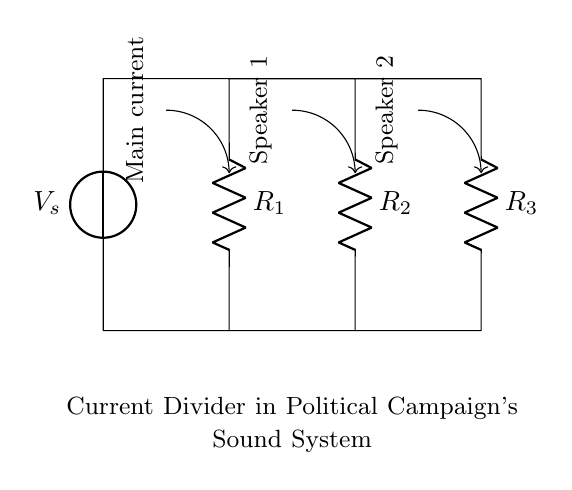What is the source voltage in the circuit? The source voltage is represented as V_s in the diagram, indicating the potential difference provided for the circuit operation.
Answer: V_s How many resistors are present in the circuit? The diagram shows three resistors labeled R_1, R_2, and R_3, indicating that there are three resistors in total.
Answer: 3 Which resistor connects to Speaker 1? Speaker 1 is connected to the output of resistor R_2, as indicated by the arrow leading to it from the current flowing through R_2.
Answer: R_2 What is the function of the current divider in this circuit? The current divider is designed to split the main current into two branches leading to the speakers, allowing for sound distribution among multiple outputs.
Answer: To split current Which component primarily directs the current toward both speakers? The main current flows from the voltage source through the resistors effectively directing the current toward both speakers; the resistors primarily serve this purpose.
Answer: Resistors What current path is formed between the speakers? The current path consists of two separate routes after the main current passes through the resistors, allowing the current to flow to both Speaker 1 and Speaker 2.
Answer: Two paths 